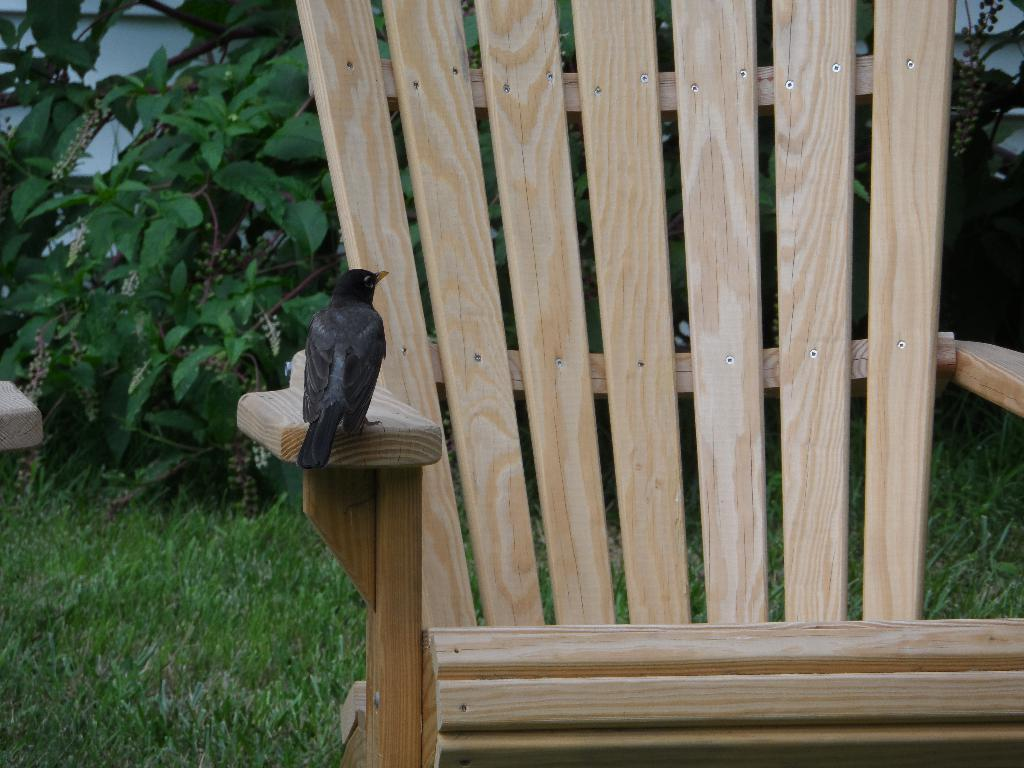What type of animal is in the image? There is a bird in the image. Where is the bird located? The bird is resting on a wooden chair. What is the ground made of in the image? There is grass on the ground in the image. What type of vegetation can be seen in the image? There are plants visible in the image. What kind of trouble is the bird causing in the image? There is no indication of trouble or any negative actions by the bird in the image. 